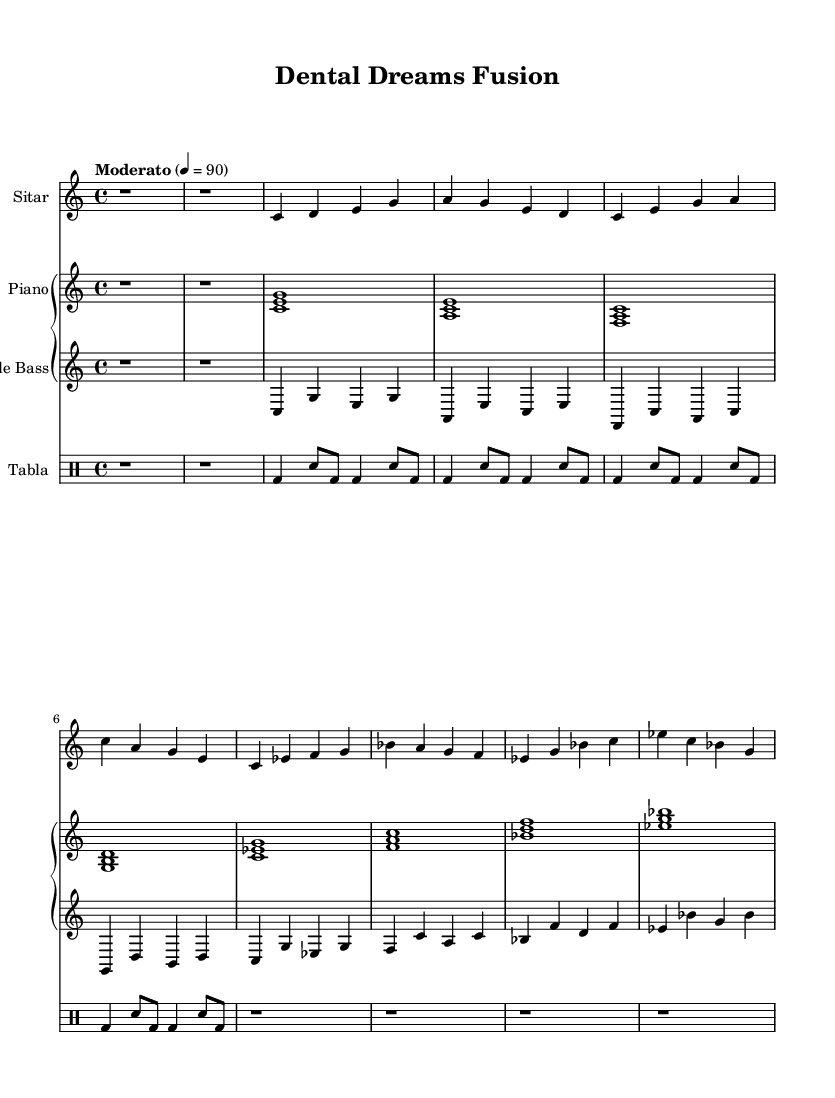What is the key signature of this music? The key signature is C major, which has no sharps or flats indicated at the beginning of the staff.
Answer: C major What is the time signature of the piece? The time signature is indicated as 4/4, which means there are four beats in each measure. This is found at the beginning of the score, right next to the key signature.
Answer: 4/4 What is the tempo marking of this composition? The tempo marking is "Moderato," which indicates a moderate pace, specifically noted with 4 = 90, meaning there are 90 beats per minute. This can be found at the top of the score.
Answer: Moderato How many beats are in the first measure of the sitar? The first measure of the sitar has a rest value of one whole note (r1), which corresponds to four beats. This is observed directly from the notation at the start of the staff.
Answer: Four Which instruments are performing the jazz bridge? The jazz bridge is performed by the sitar, piano, and bass, as indicated by their rest measures of the tabla during this section. Each of these instruments enters the corresponding measures for the jazz bridge.
Answer: Sitar, Piano, Bass What rhythmic pattern does the tabla use in the main theme? The tabla follows a simplified Dadra Taal pattern in the main theme, comprising alternating bass (bd) and snare (sn) notes, as shown in its rhythmic notations.
Answer: Dadra Taal What is the highest pitch note played in the piano part? The highest pitch note in the piano part is B, specifically occurring in the chord <g b d> which appears in the jazz bridge section. This observation can be made by analyzing the notes played throughout the sections.
Answer: B 